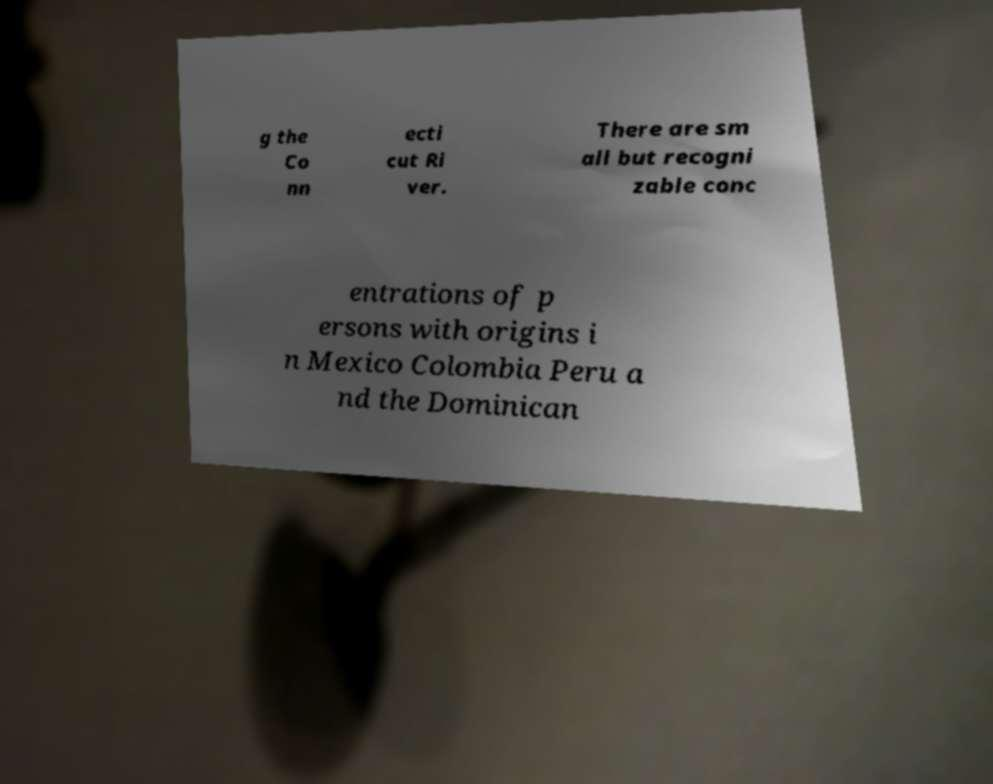Could you assist in decoding the text presented in this image and type it out clearly? g the Co nn ecti cut Ri ver. There are sm all but recogni zable conc entrations of p ersons with origins i n Mexico Colombia Peru a nd the Dominican 